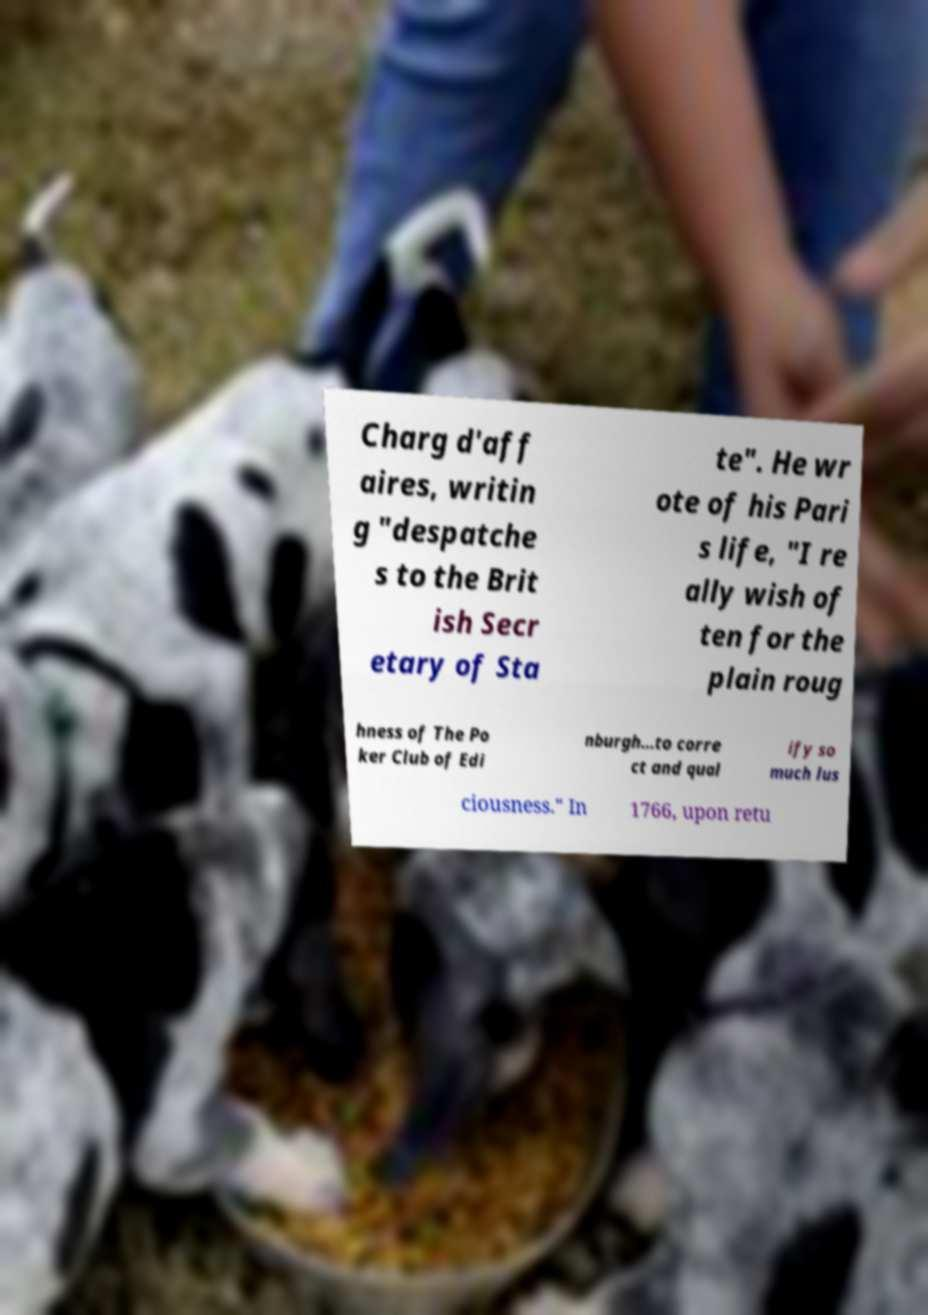There's text embedded in this image that I need extracted. Can you transcribe it verbatim? Charg d'aff aires, writin g "despatche s to the Brit ish Secr etary of Sta te". He wr ote of his Pari s life, "I re ally wish of ten for the plain roug hness of The Po ker Club of Edi nburgh…to corre ct and qual ify so much lus ciousness." In 1766, upon retu 